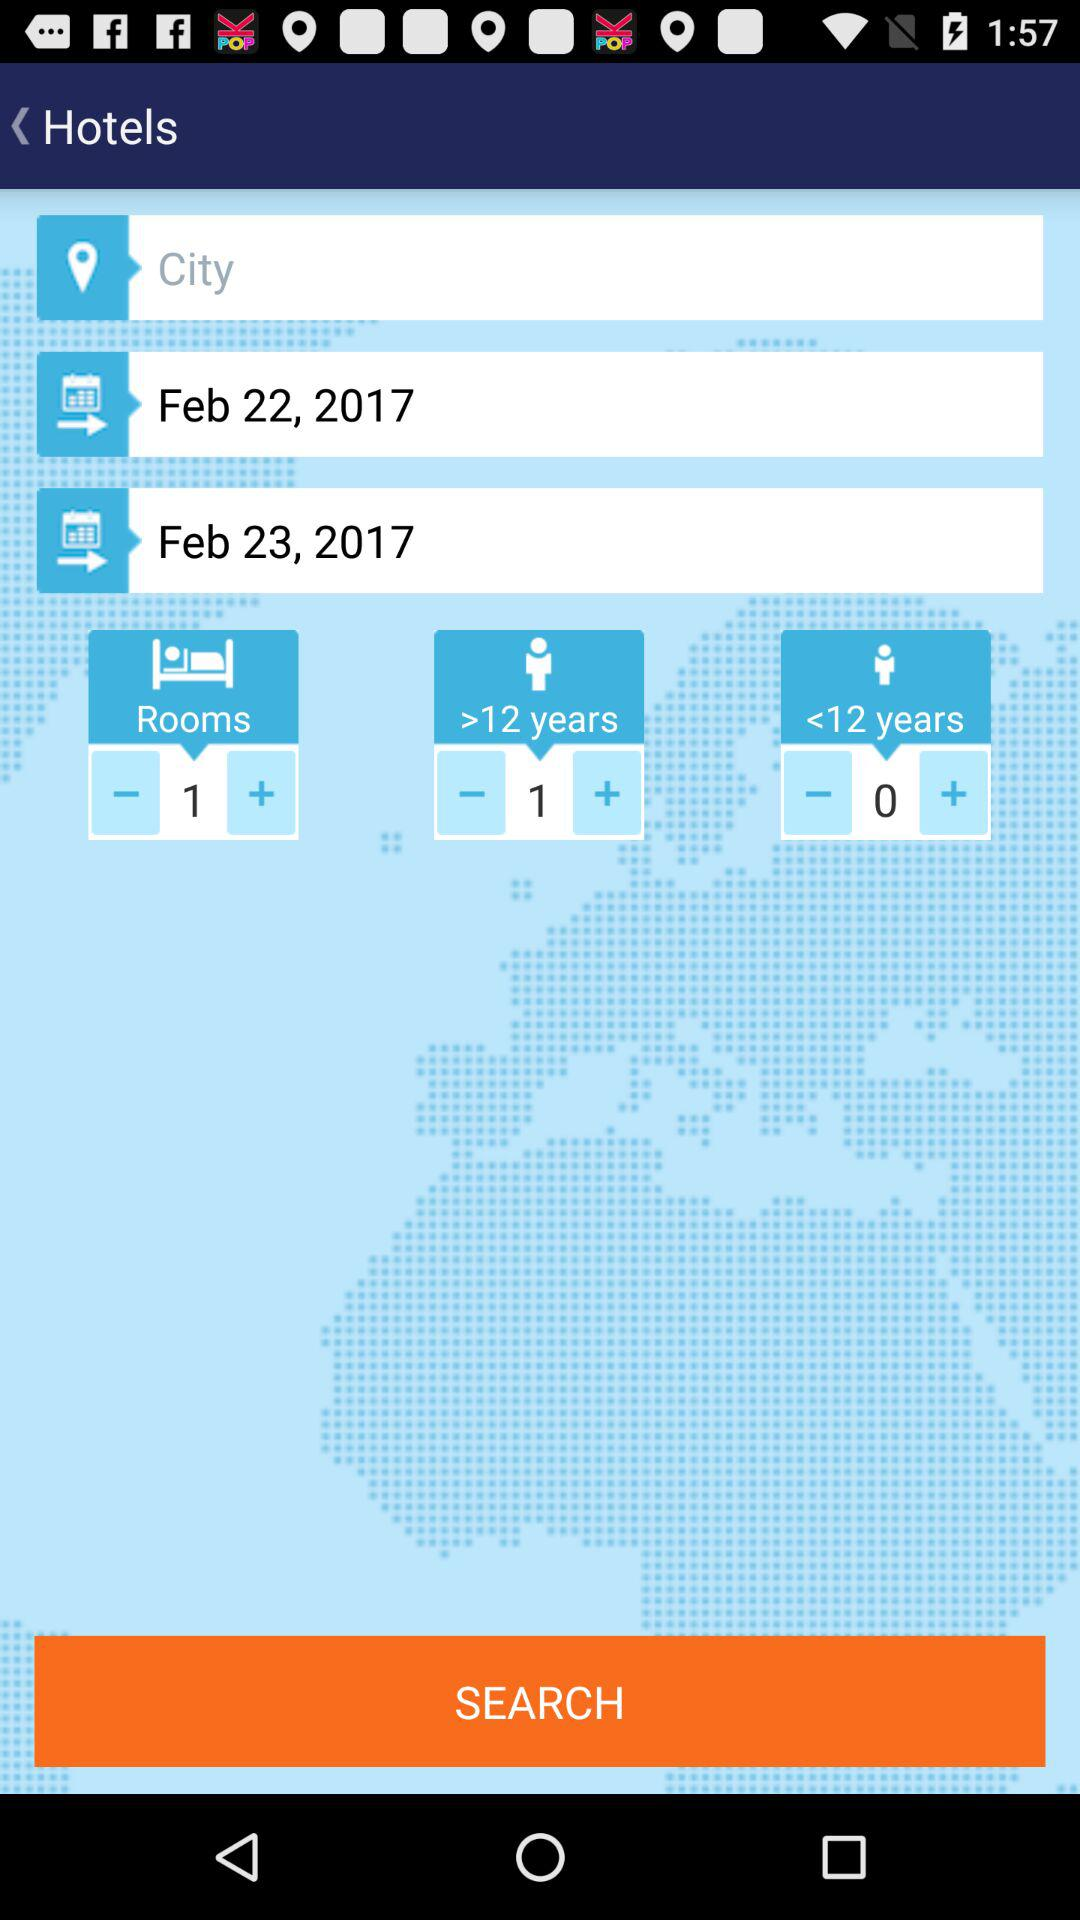How many rooms are selected? There is one room selected. 